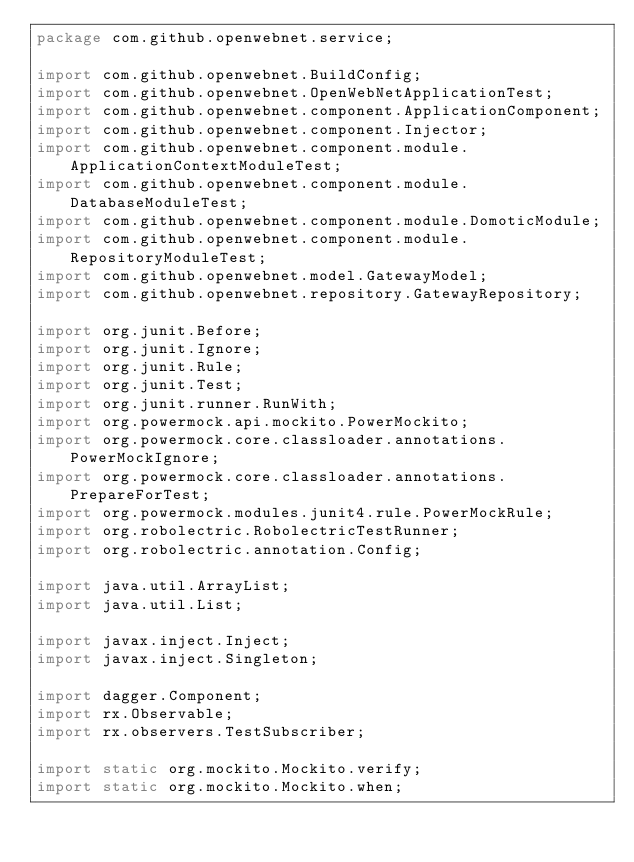Convert code to text. <code><loc_0><loc_0><loc_500><loc_500><_Java_>package com.github.openwebnet.service;

import com.github.openwebnet.BuildConfig;
import com.github.openwebnet.OpenWebNetApplicationTest;
import com.github.openwebnet.component.ApplicationComponent;
import com.github.openwebnet.component.Injector;
import com.github.openwebnet.component.module.ApplicationContextModuleTest;
import com.github.openwebnet.component.module.DatabaseModuleTest;
import com.github.openwebnet.component.module.DomoticModule;
import com.github.openwebnet.component.module.RepositoryModuleTest;
import com.github.openwebnet.model.GatewayModel;
import com.github.openwebnet.repository.GatewayRepository;

import org.junit.Before;
import org.junit.Ignore;
import org.junit.Rule;
import org.junit.Test;
import org.junit.runner.RunWith;
import org.powermock.api.mockito.PowerMockito;
import org.powermock.core.classloader.annotations.PowerMockIgnore;
import org.powermock.core.classloader.annotations.PrepareForTest;
import org.powermock.modules.junit4.rule.PowerMockRule;
import org.robolectric.RobolectricTestRunner;
import org.robolectric.annotation.Config;

import java.util.ArrayList;
import java.util.List;

import javax.inject.Inject;
import javax.inject.Singleton;

import dagger.Component;
import rx.Observable;
import rx.observers.TestSubscriber;

import static org.mockito.Mockito.verify;
import static org.mockito.Mockito.when;
</code> 